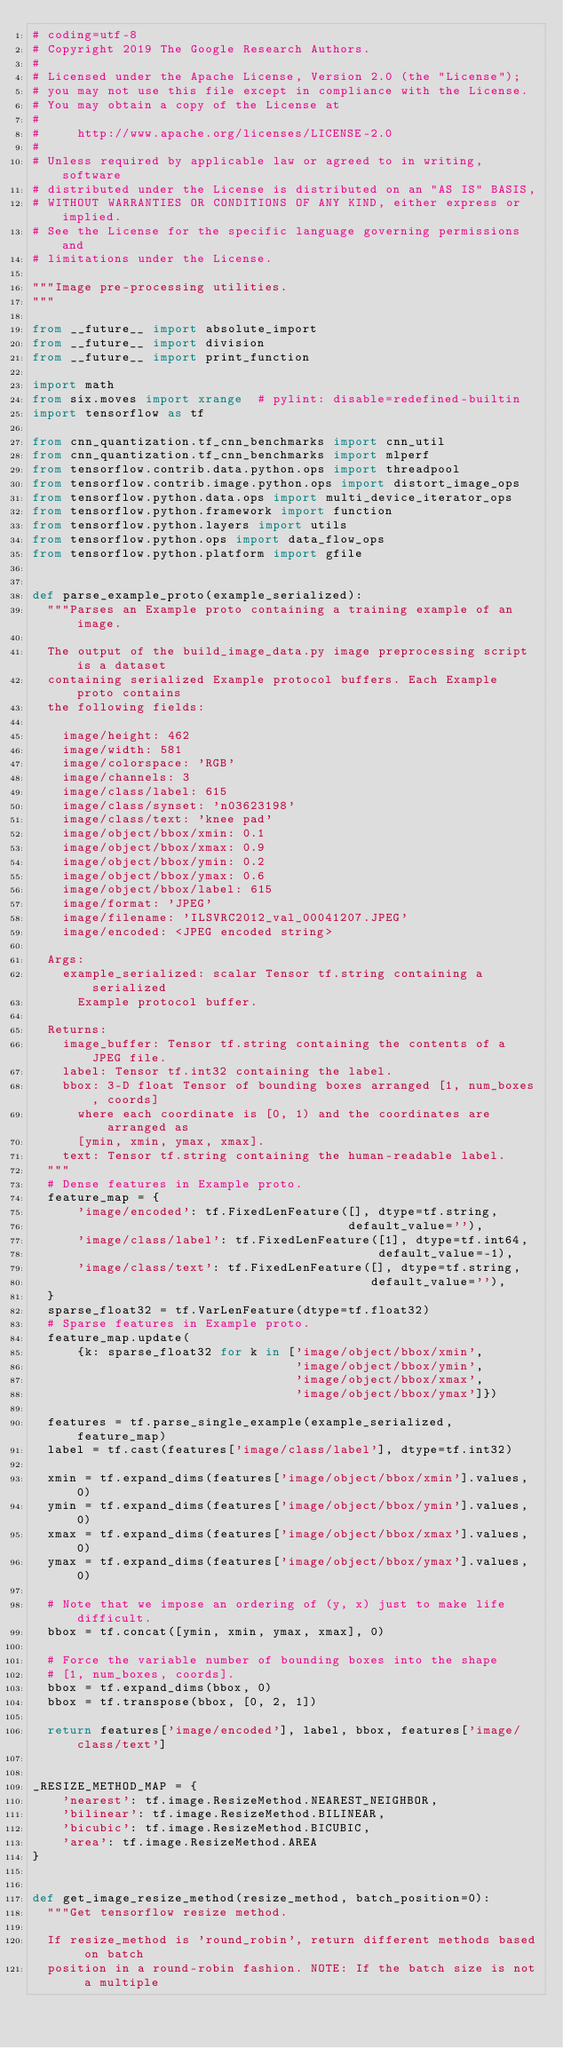Convert code to text. <code><loc_0><loc_0><loc_500><loc_500><_Python_># coding=utf-8
# Copyright 2019 The Google Research Authors.
#
# Licensed under the Apache License, Version 2.0 (the "License");
# you may not use this file except in compliance with the License.
# You may obtain a copy of the License at
#
#     http://www.apache.org/licenses/LICENSE-2.0
#
# Unless required by applicable law or agreed to in writing, software
# distributed under the License is distributed on an "AS IS" BASIS,
# WITHOUT WARRANTIES OR CONDITIONS OF ANY KIND, either express or implied.
# See the License for the specific language governing permissions and
# limitations under the License.

"""Image pre-processing utilities.
"""

from __future__ import absolute_import
from __future__ import division
from __future__ import print_function

import math
from six.moves import xrange  # pylint: disable=redefined-builtin
import tensorflow as tf

from cnn_quantization.tf_cnn_benchmarks import cnn_util
from cnn_quantization.tf_cnn_benchmarks import mlperf
from tensorflow.contrib.data.python.ops import threadpool
from tensorflow.contrib.image.python.ops import distort_image_ops
from tensorflow.python.data.ops import multi_device_iterator_ops
from tensorflow.python.framework import function
from tensorflow.python.layers import utils
from tensorflow.python.ops import data_flow_ops
from tensorflow.python.platform import gfile


def parse_example_proto(example_serialized):
  """Parses an Example proto containing a training example of an image.

  The output of the build_image_data.py image preprocessing script is a dataset
  containing serialized Example protocol buffers. Each Example proto contains
  the following fields:

    image/height: 462
    image/width: 581
    image/colorspace: 'RGB'
    image/channels: 3
    image/class/label: 615
    image/class/synset: 'n03623198'
    image/class/text: 'knee pad'
    image/object/bbox/xmin: 0.1
    image/object/bbox/xmax: 0.9
    image/object/bbox/ymin: 0.2
    image/object/bbox/ymax: 0.6
    image/object/bbox/label: 615
    image/format: 'JPEG'
    image/filename: 'ILSVRC2012_val_00041207.JPEG'
    image/encoded: <JPEG encoded string>

  Args:
    example_serialized: scalar Tensor tf.string containing a serialized
      Example protocol buffer.

  Returns:
    image_buffer: Tensor tf.string containing the contents of a JPEG file.
    label: Tensor tf.int32 containing the label.
    bbox: 3-D float Tensor of bounding boxes arranged [1, num_boxes, coords]
      where each coordinate is [0, 1) and the coordinates are arranged as
      [ymin, xmin, ymax, xmax].
    text: Tensor tf.string containing the human-readable label.
  """
  # Dense features in Example proto.
  feature_map = {
      'image/encoded': tf.FixedLenFeature([], dtype=tf.string,
                                          default_value=''),
      'image/class/label': tf.FixedLenFeature([1], dtype=tf.int64,
                                              default_value=-1),
      'image/class/text': tf.FixedLenFeature([], dtype=tf.string,
                                             default_value=''),
  }
  sparse_float32 = tf.VarLenFeature(dtype=tf.float32)
  # Sparse features in Example proto.
  feature_map.update(
      {k: sparse_float32 for k in ['image/object/bbox/xmin',
                                   'image/object/bbox/ymin',
                                   'image/object/bbox/xmax',
                                   'image/object/bbox/ymax']})

  features = tf.parse_single_example(example_serialized, feature_map)
  label = tf.cast(features['image/class/label'], dtype=tf.int32)

  xmin = tf.expand_dims(features['image/object/bbox/xmin'].values, 0)
  ymin = tf.expand_dims(features['image/object/bbox/ymin'].values, 0)
  xmax = tf.expand_dims(features['image/object/bbox/xmax'].values, 0)
  ymax = tf.expand_dims(features['image/object/bbox/ymax'].values, 0)

  # Note that we impose an ordering of (y, x) just to make life difficult.
  bbox = tf.concat([ymin, xmin, ymax, xmax], 0)

  # Force the variable number of bounding boxes into the shape
  # [1, num_boxes, coords].
  bbox = tf.expand_dims(bbox, 0)
  bbox = tf.transpose(bbox, [0, 2, 1])

  return features['image/encoded'], label, bbox, features['image/class/text']


_RESIZE_METHOD_MAP = {
    'nearest': tf.image.ResizeMethod.NEAREST_NEIGHBOR,
    'bilinear': tf.image.ResizeMethod.BILINEAR,
    'bicubic': tf.image.ResizeMethod.BICUBIC,
    'area': tf.image.ResizeMethod.AREA
}


def get_image_resize_method(resize_method, batch_position=0):
  """Get tensorflow resize method.

  If resize_method is 'round_robin', return different methods based on batch
  position in a round-robin fashion. NOTE: If the batch size is not a multiple</code> 